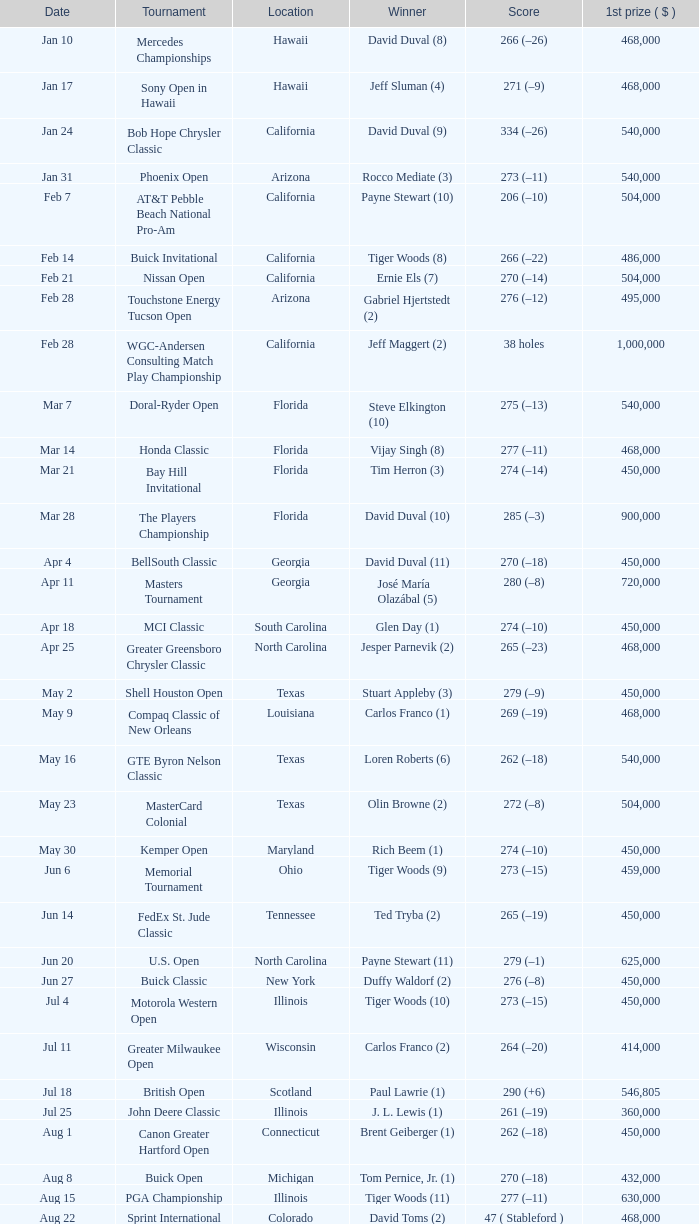Who is the winner of the tournament in Georgia on Oct 3? David Toms (3). 